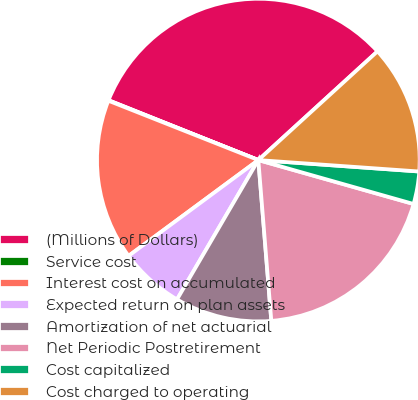Convert chart. <chart><loc_0><loc_0><loc_500><loc_500><pie_chart><fcel>(Millions of Dollars)<fcel>Service cost<fcel>Interest cost on accumulated<fcel>Expected return on plan assets<fcel>Amortization of net actuarial<fcel>Net Periodic Postretirement<fcel>Cost capitalized<fcel>Cost charged to operating<nl><fcel>32.18%<fcel>0.05%<fcel>16.12%<fcel>6.47%<fcel>9.69%<fcel>19.33%<fcel>3.26%<fcel>12.9%<nl></chart> 